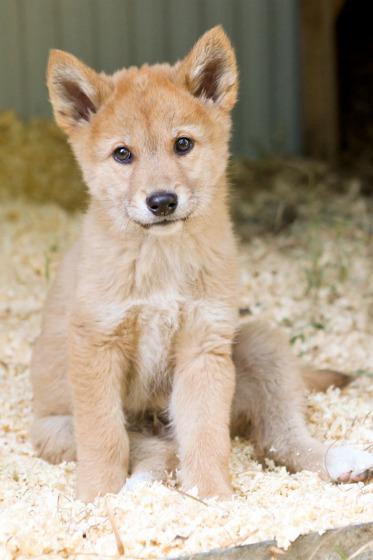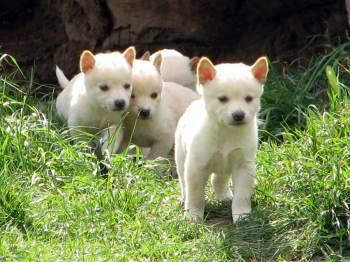The first image is the image on the left, the second image is the image on the right. For the images shown, is this caption "There are more canines in the left image than the right." true? Answer yes or no. No. 